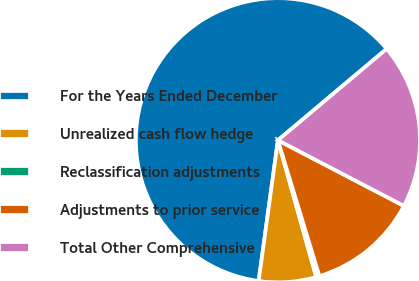<chart> <loc_0><loc_0><loc_500><loc_500><pie_chart><fcel>For the Years Ended December<fcel>Unrealized cash flow hedge<fcel>Reclassification adjustments<fcel>Adjustments to prior service<fcel>Total Other Comprehensive<nl><fcel>61.7%<fcel>6.51%<fcel>0.37%<fcel>12.64%<fcel>18.77%<nl></chart> 